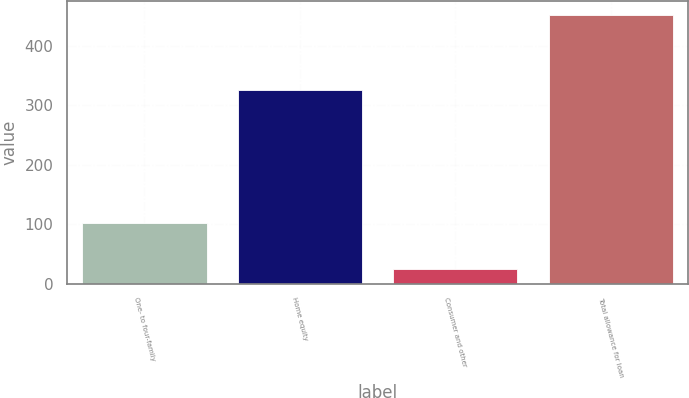Convert chart. <chart><loc_0><loc_0><loc_500><loc_500><bar_chart><fcel>One- to four-family<fcel>Home equity<fcel>Consumer and other<fcel>Total allowance for loan<nl><fcel>102<fcel>326<fcel>25<fcel>453<nl></chart> 